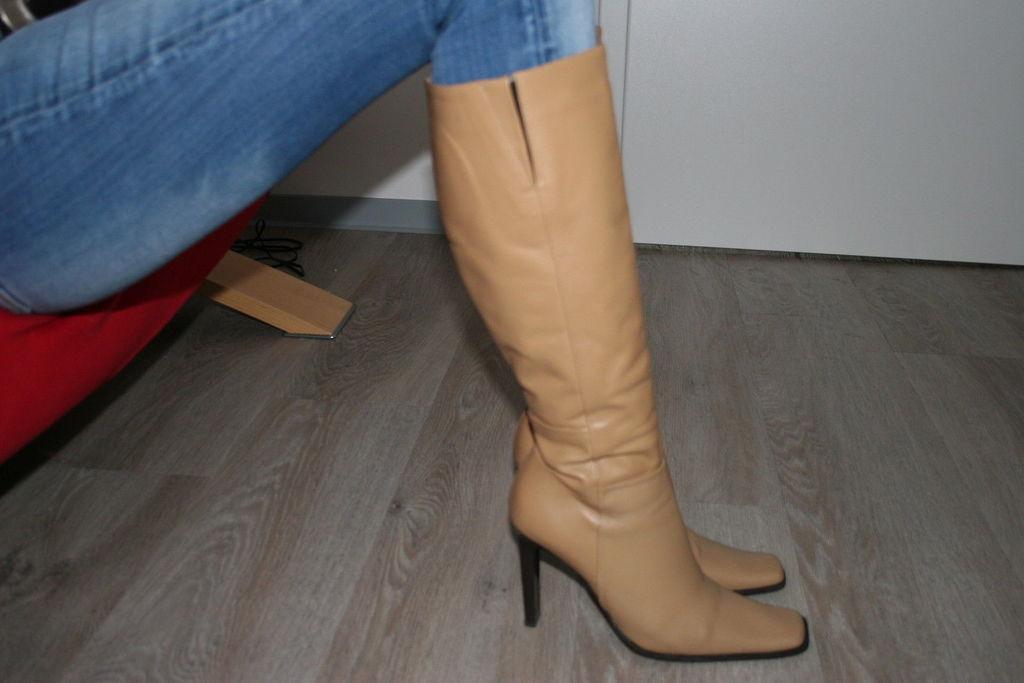Could you give a brief overview of what you see in this image? In this image we can see a person legs with boots and there is a red color object looks like a chair and there is a wooden floor and white color wall in the background. 